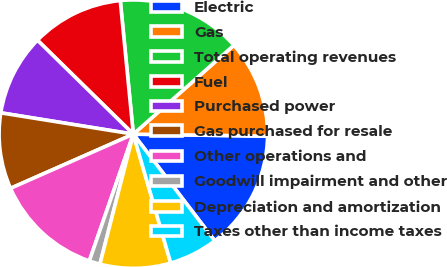Convert chart to OTSL. <chart><loc_0><loc_0><loc_500><loc_500><pie_chart><fcel>Electric<fcel>Gas<fcel>Total operating revenues<fcel>Fuel<fcel>Purchased power<fcel>Gas purchased for resale<fcel>Other operations and<fcel>Goodwill impairment and other<fcel>Depreciation and amortization<fcel>Taxes other than income taxes<nl><fcel>14.38%<fcel>11.76%<fcel>15.03%<fcel>11.11%<fcel>9.8%<fcel>9.15%<fcel>13.07%<fcel>1.31%<fcel>8.5%<fcel>5.88%<nl></chart> 